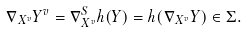Convert formula to latex. <formula><loc_0><loc_0><loc_500><loc_500>\nabla _ { X ^ { v } } Y ^ { v } = \nabla _ { X ^ { v } } ^ { S } h ( Y ) = h ( \nabla _ { X ^ { v } } Y ) \in \Sigma .</formula> 